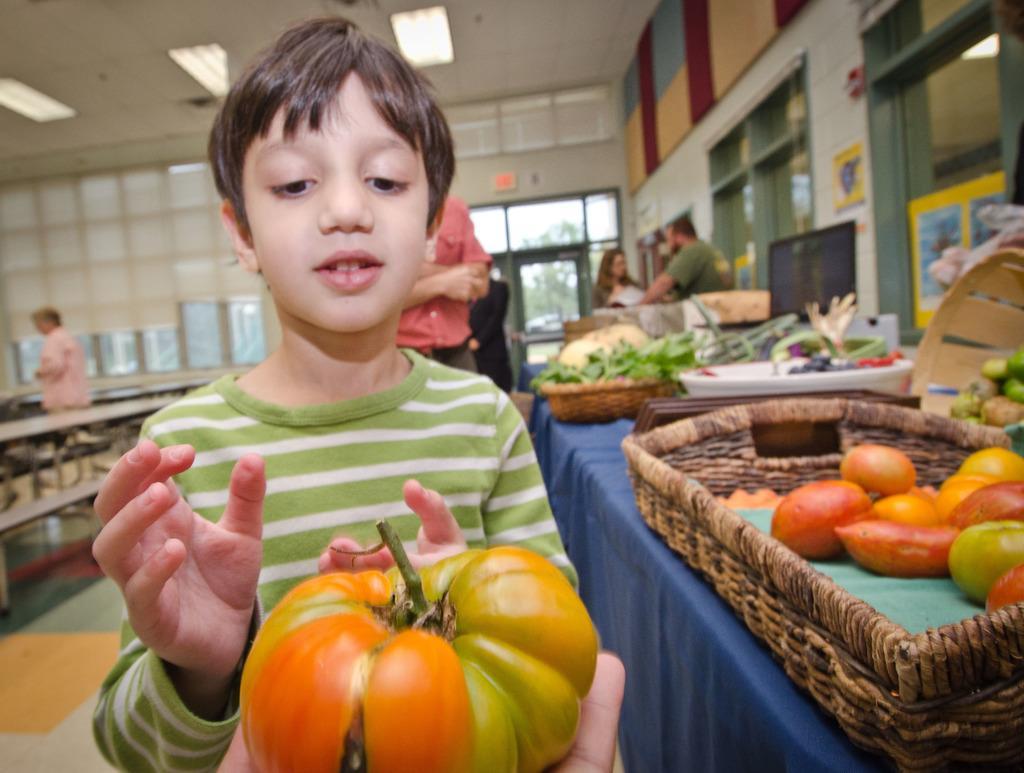In one or two sentences, can you explain what this image depicts? In this picture I can see a person's hand on which, I can see a pumpkin and I can see a boy in front who is standing. On the right side of this picture I can see the table on which there are baskets and on the baskets I can see few vegetables. In the background I can see few people, windows and lights on the ceiling. 